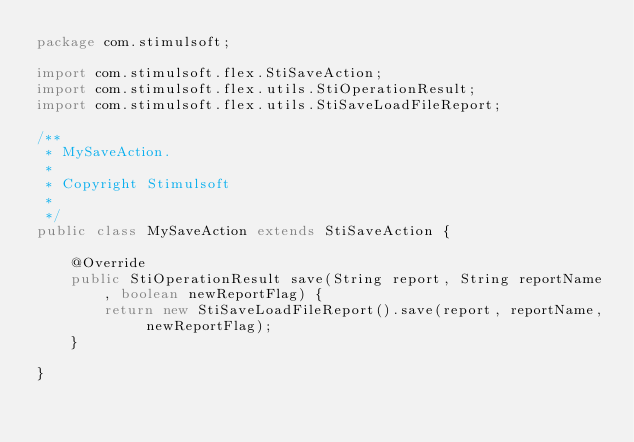<code> <loc_0><loc_0><loc_500><loc_500><_Java_>package com.stimulsoft;

import com.stimulsoft.flex.StiSaveAction;
import com.stimulsoft.flex.utils.StiOperationResult;
import com.stimulsoft.flex.utils.StiSaveLoadFileReport;

/**
 * MySaveAction.
 * 
 * Copyright Stimulsoft
 * 
 */
public class MySaveAction extends StiSaveAction {

    @Override
    public StiOperationResult save(String report, String reportName, boolean newReportFlag) {
        return new StiSaveLoadFileReport().save(report, reportName, newReportFlag);
    }

}
</code> 